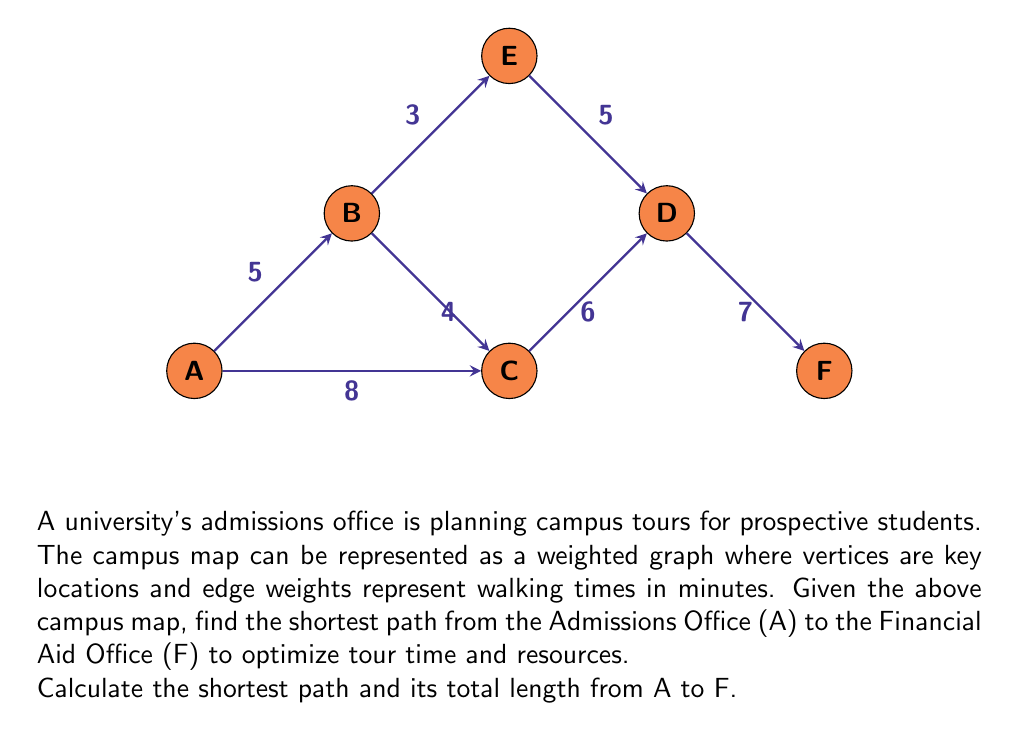What is the answer to this math problem? To solve this problem, we can use Dijkstra's algorithm to find the shortest path from vertex A to vertex F. Let's go through the steps:

1) Initialize distances:
   $d(A) = 0$, $d(B) = \infty$, $d(C) = \infty$, $d(D) = \infty$, $d(E) = \infty$, $d(F) = \infty$

2) Start from vertex A:
   Update neighbors of A:
   $d(B) = \min(\infty, 0 + 5) = 5$
   $d(C) = \min(\infty, 0 + 8) = 8$

3) Select the vertex with the smallest distance (B):
   Update neighbors of B:
   $d(C) = \min(8, 5 + 4) = 8$ (no change)
   $d(E) = \min(\infty, 5 + 3) = 8$

4) Select the next smallest distance (C):
   Update neighbors of C:
   $d(D) = \min(\infty, 8 + 6) = 14$

5) Select the next smallest distance (E):
   Update neighbors of E:
   $d(D) = \min(14, 8 + 5) = 13$

6) Select the next smallest distance (D):
   Update neighbors of D:
   $d(F) = \min(\infty, 13 + 7) = 20$

7) The algorithm terminates as we've reached F.

The shortest path from A to F is A → B → E → D → F with a total length of 20 minutes.
Answer: A → B → E → D → F, 20 minutes 